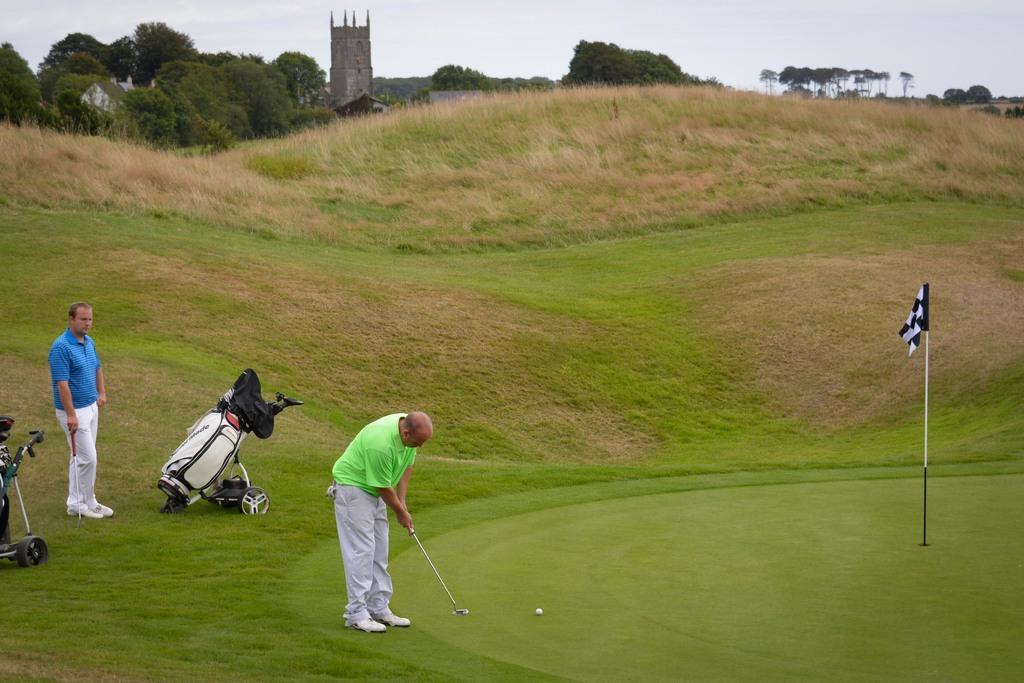In one or two sentences, can you explain what this image depicts? In this picture I can see a man who is standing in front and I see that he is holding a golf bat in his hands and I see a ball near to him and on the right of this image I see a flag on a pole and on the left side of this image I see a man who is standing and holding a golf bat in his hand and I see 2 things near to him. In the background I see the grass, trees, few buildings and the sky. 